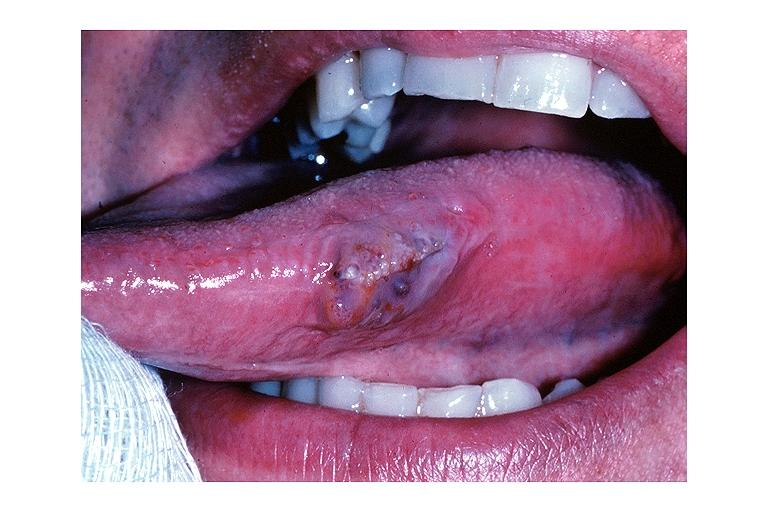where is this?
Answer the question using a single word or phrase. Oral 